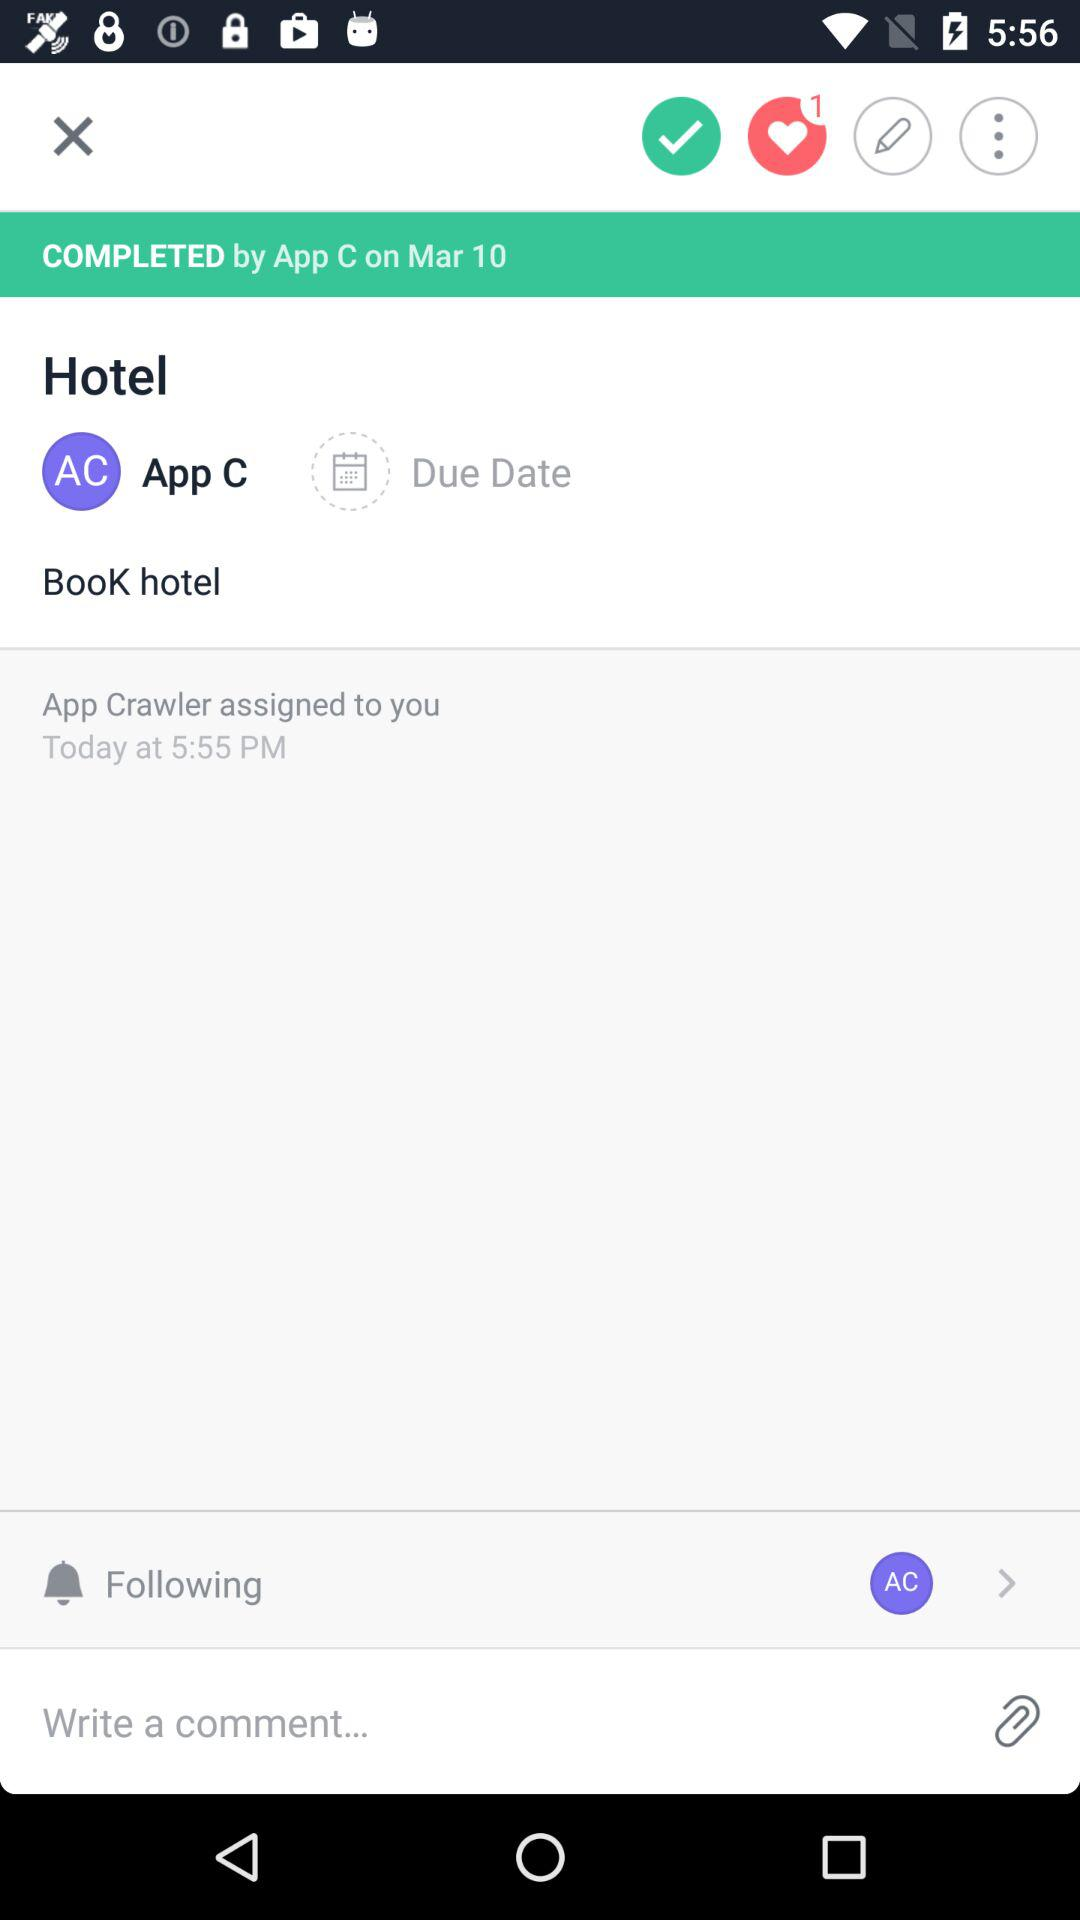What is the date assigned by App Crawler?
When the provided information is insufficient, respond with <no answer>. <no answer> 